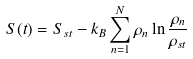<formula> <loc_0><loc_0><loc_500><loc_500>S ( t ) = S _ { s t } - k _ { B } \sum _ { n = 1 } ^ { N } \rho _ { n } \ln \frac { \rho _ { n } } { \rho _ { s t } }</formula> 